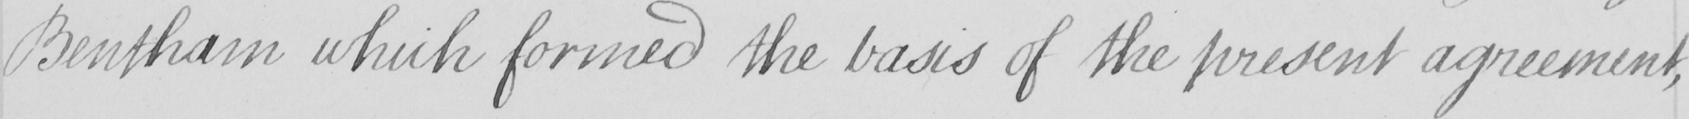Please provide the text content of this handwritten line. Bentham which formed the basis of the present agreement , 